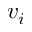Convert formula to latex. <formula><loc_0><loc_0><loc_500><loc_500>v _ { i }</formula> 